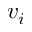Convert formula to latex. <formula><loc_0><loc_0><loc_500><loc_500>v _ { i }</formula> 